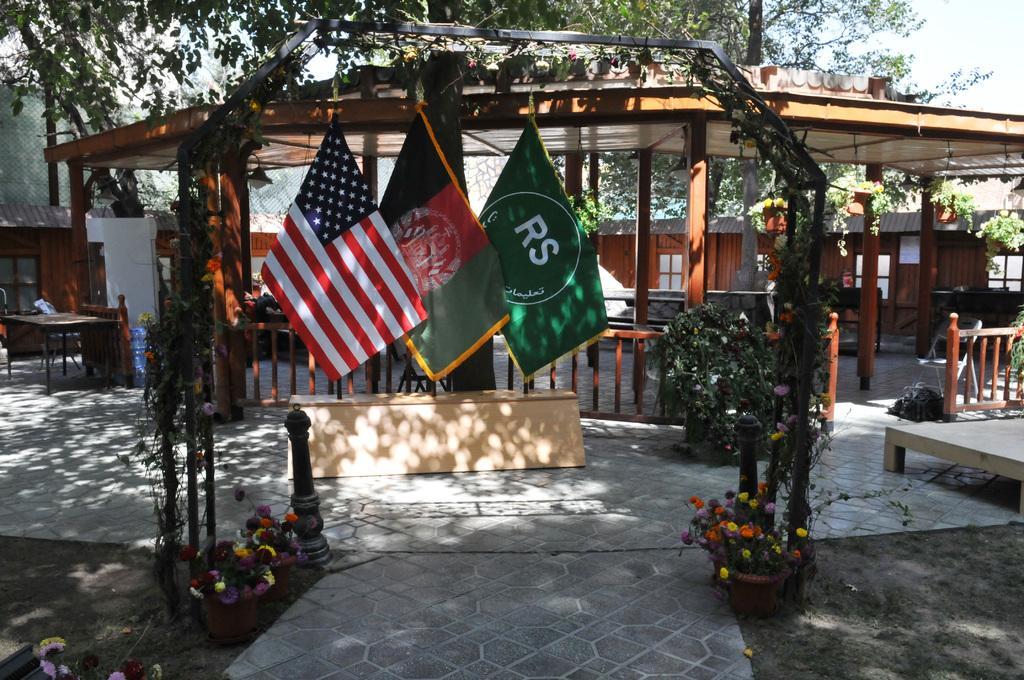How would you summarize this image in a sentence or two? In this picture there are three flags attached to a pole which are placed on a wooden object and there is a wooden fence behind it and there is a roof above it and there are trees and a fence in the background. 